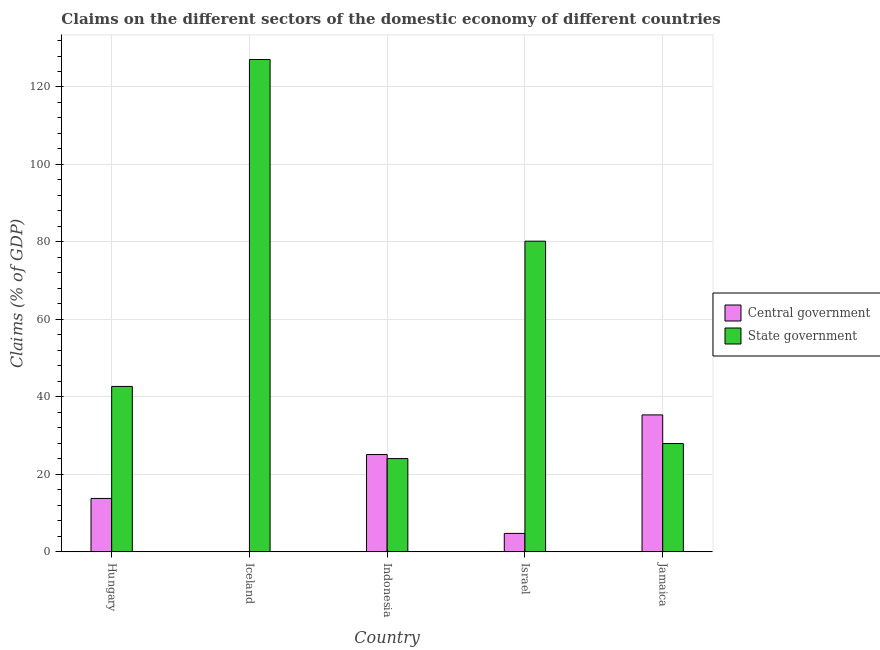How many different coloured bars are there?
Your answer should be very brief. 2. Are the number of bars per tick equal to the number of legend labels?
Offer a terse response. No. Are the number of bars on each tick of the X-axis equal?
Your response must be concise. No. How many bars are there on the 2nd tick from the left?
Keep it short and to the point. 1. How many bars are there on the 1st tick from the right?
Keep it short and to the point. 2. What is the claims on state government in Israel?
Give a very brief answer. 80.2. Across all countries, what is the maximum claims on state government?
Your answer should be compact. 127.1. Across all countries, what is the minimum claims on central government?
Your answer should be very brief. 0. In which country was the claims on central government maximum?
Make the answer very short. Jamaica. What is the total claims on central government in the graph?
Provide a short and direct response. 79.04. What is the difference between the claims on central government in Hungary and that in Indonesia?
Provide a short and direct response. -11.33. What is the difference between the claims on state government in Israel and the claims on central government in Indonesia?
Your response must be concise. 55.08. What is the average claims on state government per country?
Your response must be concise. 60.41. What is the difference between the claims on central government and claims on state government in Israel?
Make the answer very short. -75.43. What is the ratio of the claims on central government in Hungary to that in Indonesia?
Your response must be concise. 0.55. What is the difference between the highest and the second highest claims on central government?
Make the answer very short. 10.23. What is the difference between the highest and the lowest claims on central government?
Provide a succinct answer. 35.36. In how many countries, is the claims on central government greater than the average claims on central government taken over all countries?
Ensure brevity in your answer.  2. Is the sum of the claims on state government in Iceland and Israel greater than the maximum claims on central government across all countries?
Ensure brevity in your answer.  Yes. How many bars are there?
Provide a succinct answer. 9. Are the values on the major ticks of Y-axis written in scientific E-notation?
Provide a succinct answer. No. Where does the legend appear in the graph?
Provide a short and direct response. Center right. How are the legend labels stacked?
Keep it short and to the point. Vertical. What is the title of the graph?
Your answer should be very brief. Claims on the different sectors of the domestic economy of different countries. What is the label or title of the Y-axis?
Ensure brevity in your answer.  Claims (% of GDP). What is the Claims (% of GDP) of Central government in Hungary?
Your answer should be compact. 13.79. What is the Claims (% of GDP) of State government in Hungary?
Make the answer very short. 42.71. What is the Claims (% of GDP) of Central government in Iceland?
Keep it short and to the point. 0. What is the Claims (% of GDP) in State government in Iceland?
Offer a terse response. 127.1. What is the Claims (% of GDP) in Central government in Indonesia?
Give a very brief answer. 25.13. What is the Claims (% of GDP) in State government in Indonesia?
Ensure brevity in your answer.  24.08. What is the Claims (% of GDP) of Central government in Israel?
Provide a short and direct response. 4.77. What is the Claims (% of GDP) of State government in Israel?
Your answer should be very brief. 80.2. What is the Claims (% of GDP) in Central government in Jamaica?
Provide a succinct answer. 35.36. What is the Claims (% of GDP) in State government in Jamaica?
Keep it short and to the point. 27.96. Across all countries, what is the maximum Claims (% of GDP) of Central government?
Your answer should be compact. 35.36. Across all countries, what is the maximum Claims (% of GDP) of State government?
Make the answer very short. 127.1. Across all countries, what is the minimum Claims (% of GDP) in Central government?
Provide a succinct answer. 0. Across all countries, what is the minimum Claims (% of GDP) of State government?
Your answer should be compact. 24.08. What is the total Claims (% of GDP) in Central government in the graph?
Keep it short and to the point. 79.04. What is the total Claims (% of GDP) in State government in the graph?
Provide a succinct answer. 302.05. What is the difference between the Claims (% of GDP) of State government in Hungary and that in Iceland?
Your response must be concise. -84.39. What is the difference between the Claims (% of GDP) of Central government in Hungary and that in Indonesia?
Your answer should be compact. -11.33. What is the difference between the Claims (% of GDP) of State government in Hungary and that in Indonesia?
Offer a terse response. 18.63. What is the difference between the Claims (% of GDP) in Central government in Hungary and that in Israel?
Provide a succinct answer. 9.02. What is the difference between the Claims (% of GDP) in State government in Hungary and that in Israel?
Offer a terse response. -37.5. What is the difference between the Claims (% of GDP) of Central government in Hungary and that in Jamaica?
Make the answer very short. -21.56. What is the difference between the Claims (% of GDP) in State government in Hungary and that in Jamaica?
Your response must be concise. 14.74. What is the difference between the Claims (% of GDP) of State government in Iceland and that in Indonesia?
Ensure brevity in your answer.  103.02. What is the difference between the Claims (% of GDP) of State government in Iceland and that in Israel?
Make the answer very short. 46.9. What is the difference between the Claims (% of GDP) of State government in Iceland and that in Jamaica?
Provide a short and direct response. 99.14. What is the difference between the Claims (% of GDP) of Central government in Indonesia and that in Israel?
Keep it short and to the point. 20.36. What is the difference between the Claims (% of GDP) in State government in Indonesia and that in Israel?
Your response must be concise. -56.12. What is the difference between the Claims (% of GDP) in Central government in Indonesia and that in Jamaica?
Ensure brevity in your answer.  -10.23. What is the difference between the Claims (% of GDP) of State government in Indonesia and that in Jamaica?
Offer a terse response. -3.88. What is the difference between the Claims (% of GDP) in Central government in Israel and that in Jamaica?
Provide a short and direct response. -30.59. What is the difference between the Claims (% of GDP) of State government in Israel and that in Jamaica?
Your answer should be compact. 52.24. What is the difference between the Claims (% of GDP) in Central government in Hungary and the Claims (% of GDP) in State government in Iceland?
Provide a short and direct response. -113.31. What is the difference between the Claims (% of GDP) of Central government in Hungary and the Claims (% of GDP) of State government in Indonesia?
Offer a terse response. -10.29. What is the difference between the Claims (% of GDP) in Central government in Hungary and the Claims (% of GDP) in State government in Israel?
Keep it short and to the point. -66.41. What is the difference between the Claims (% of GDP) in Central government in Hungary and the Claims (% of GDP) in State government in Jamaica?
Keep it short and to the point. -14.17. What is the difference between the Claims (% of GDP) of Central government in Indonesia and the Claims (% of GDP) of State government in Israel?
Your response must be concise. -55.08. What is the difference between the Claims (% of GDP) in Central government in Indonesia and the Claims (% of GDP) in State government in Jamaica?
Offer a very short reply. -2.84. What is the difference between the Claims (% of GDP) of Central government in Israel and the Claims (% of GDP) of State government in Jamaica?
Provide a succinct answer. -23.19. What is the average Claims (% of GDP) of Central government per country?
Make the answer very short. 15.81. What is the average Claims (% of GDP) of State government per country?
Provide a succinct answer. 60.41. What is the difference between the Claims (% of GDP) of Central government and Claims (% of GDP) of State government in Hungary?
Offer a very short reply. -28.91. What is the difference between the Claims (% of GDP) of Central government and Claims (% of GDP) of State government in Indonesia?
Your answer should be very brief. 1.05. What is the difference between the Claims (% of GDP) in Central government and Claims (% of GDP) in State government in Israel?
Ensure brevity in your answer.  -75.43. What is the difference between the Claims (% of GDP) in Central government and Claims (% of GDP) in State government in Jamaica?
Keep it short and to the point. 7.39. What is the ratio of the Claims (% of GDP) in State government in Hungary to that in Iceland?
Provide a short and direct response. 0.34. What is the ratio of the Claims (% of GDP) in Central government in Hungary to that in Indonesia?
Make the answer very short. 0.55. What is the ratio of the Claims (% of GDP) in State government in Hungary to that in Indonesia?
Ensure brevity in your answer.  1.77. What is the ratio of the Claims (% of GDP) in Central government in Hungary to that in Israel?
Keep it short and to the point. 2.89. What is the ratio of the Claims (% of GDP) in State government in Hungary to that in Israel?
Provide a short and direct response. 0.53. What is the ratio of the Claims (% of GDP) of Central government in Hungary to that in Jamaica?
Ensure brevity in your answer.  0.39. What is the ratio of the Claims (% of GDP) in State government in Hungary to that in Jamaica?
Ensure brevity in your answer.  1.53. What is the ratio of the Claims (% of GDP) of State government in Iceland to that in Indonesia?
Your answer should be very brief. 5.28. What is the ratio of the Claims (% of GDP) of State government in Iceland to that in Israel?
Offer a terse response. 1.58. What is the ratio of the Claims (% of GDP) of State government in Iceland to that in Jamaica?
Offer a terse response. 4.55. What is the ratio of the Claims (% of GDP) of Central government in Indonesia to that in Israel?
Keep it short and to the point. 5.27. What is the ratio of the Claims (% of GDP) in State government in Indonesia to that in Israel?
Your answer should be very brief. 0.3. What is the ratio of the Claims (% of GDP) in Central government in Indonesia to that in Jamaica?
Provide a short and direct response. 0.71. What is the ratio of the Claims (% of GDP) of State government in Indonesia to that in Jamaica?
Provide a succinct answer. 0.86. What is the ratio of the Claims (% of GDP) in Central government in Israel to that in Jamaica?
Keep it short and to the point. 0.13. What is the ratio of the Claims (% of GDP) of State government in Israel to that in Jamaica?
Ensure brevity in your answer.  2.87. What is the difference between the highest and the second highest Claims (% of GDP) of Central government?
Provide a succinct answer. 10.23. What is the difference between the highest and the second highest Claims (% of GDP) in State government?
Provide a succinct answer. 46.9. What is the difference between the highest and the lowest Claims (% of GDP) of Central government?
Keep it short and to the point. 35.36. What is the difference between the highest and the lowest Claims (% of GDP) in State government?
Provide a succinct answer. 103.02. 